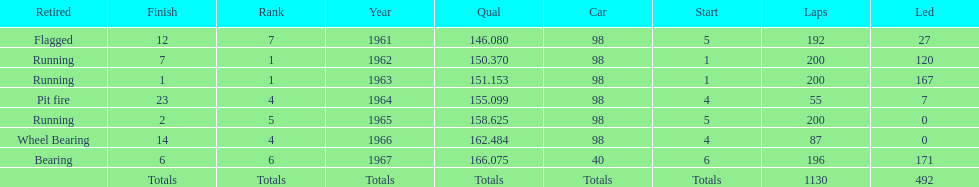In which years did he lead the race the least? 1965, 1966. 